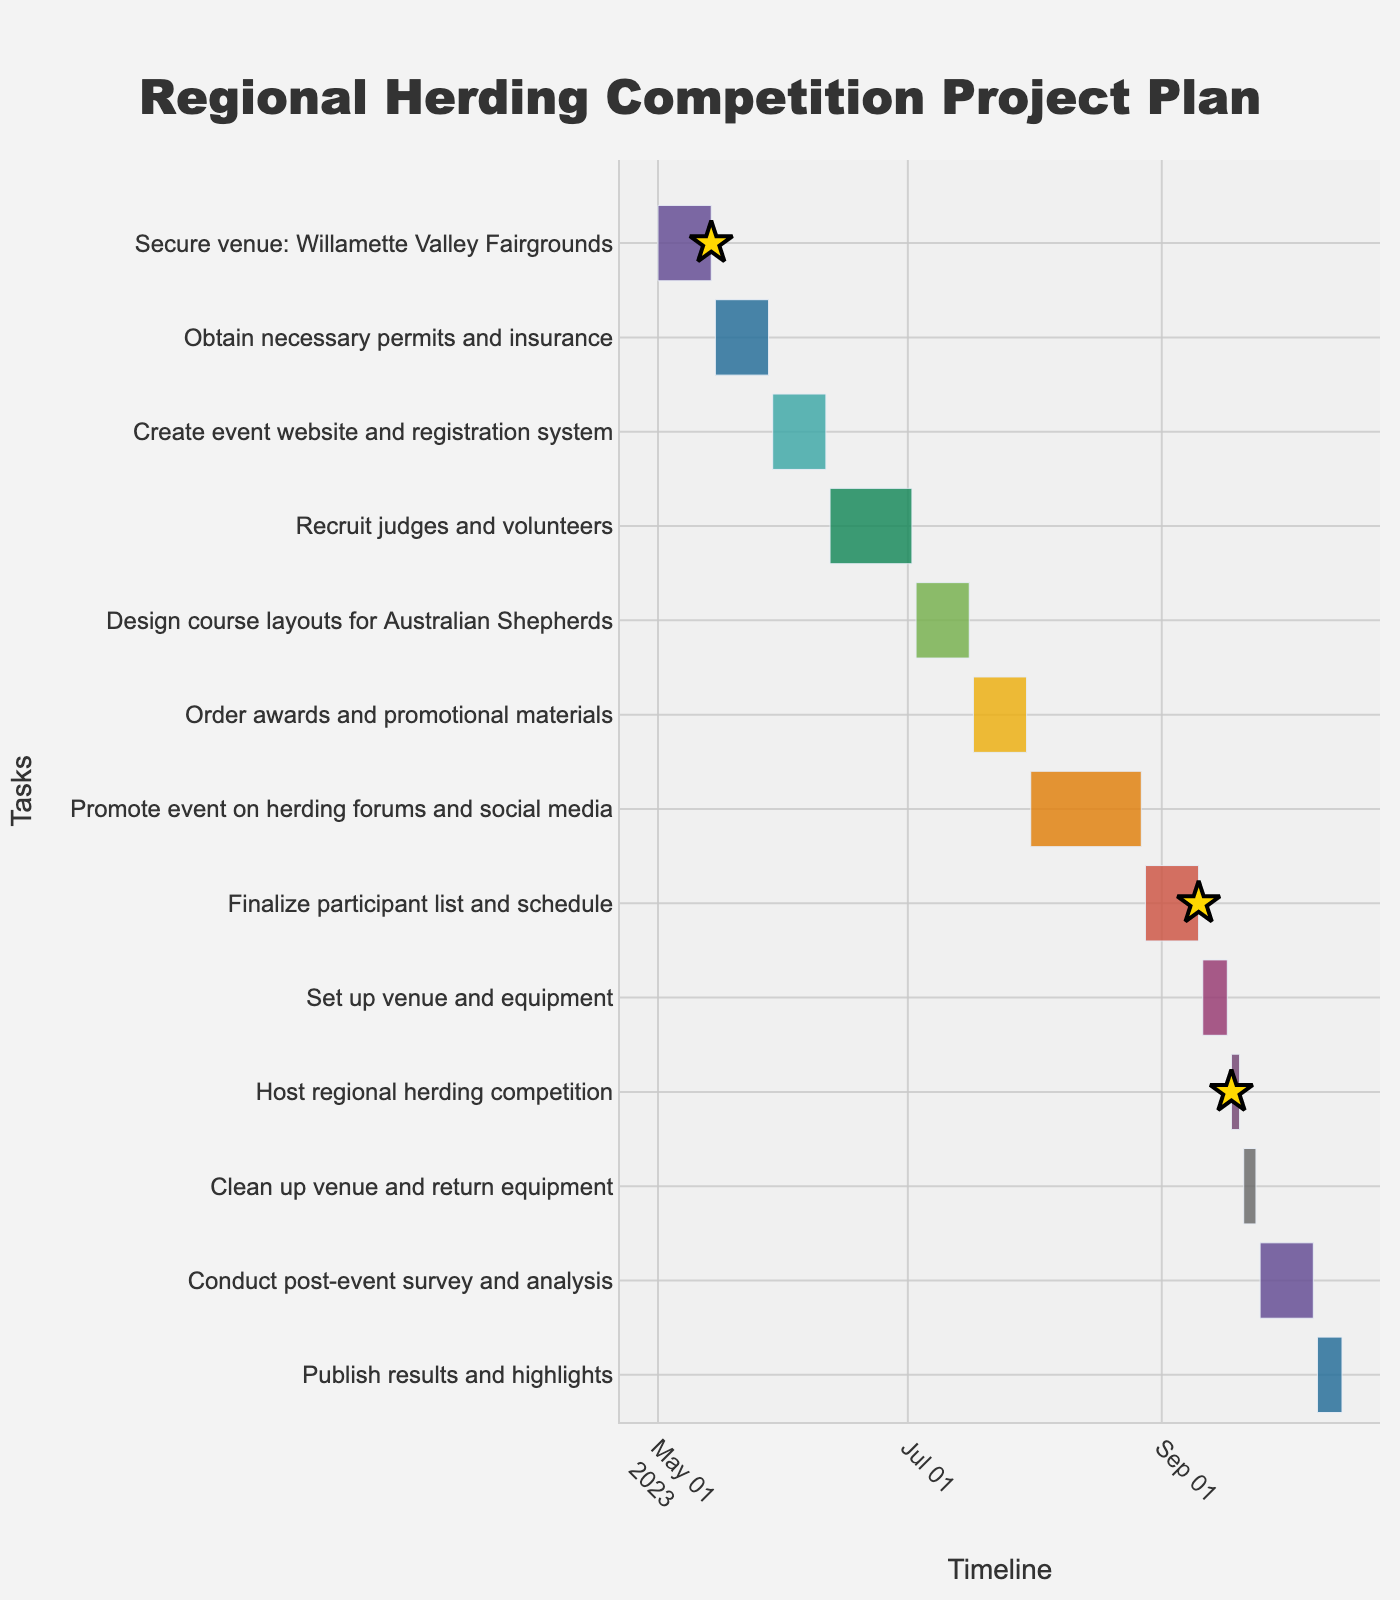What's the title of the chart? The title of the chart is centrally located at the top and clearly states the purpose of the chart.
Answer: Regional Herding Competition Project Plan When does the task "Order awards and promotional materials" start and end? You can locate the task on the y-axis and trace the start and end dates on the x-axis.
Answer: Starts on July 17, 2023, and ends on July 30, 2023 How long is the "Promote event on herding forums and social media" task? The duration of each task is typically listed as a data point.
Answer: 28 days Which tasks overlap with "Design course layouts for Australian Shepherds"? Identify the task on the y-axis and compare the dates on the x-axis with other tasks to find overlaps.
Answer: "Recruit judges and volunteers" and "Order awards and promotional materials" What is the shortest task duration? Evaluate the duration data points and identify the smallest number.
Answer: 3 days How many tasks have a duration of exactly 14 days? Count the number of tasks with a duration of 14 days listed in the data points.
Answer: 6 tasks Which milestones are marked on the chart? Look for symbols like stars and intersect the text labels for specific tasks to identify milestones.
Answer: Secure venue, Finalize participant list and schedule, and Host regional herding competition Which task ends on September 10, 2023? Locate the date on the x-axis and trace it to the corresponding task on the y-axis.
Answer: Finalize participant list and schedule Compare the length of the task "Set up venue and equipment" with "Host regional herding competition". Which one is longer? Check the durations given for both tasks directly.
Answer: Set up venue and equipment (7 days) is longer than Host regional herding competition (3 days) How many tasks are scheduled to be completed before July 2023? Check the end dates of each task and count how many are before July 1, 2023.
Answer: 3 tasks 